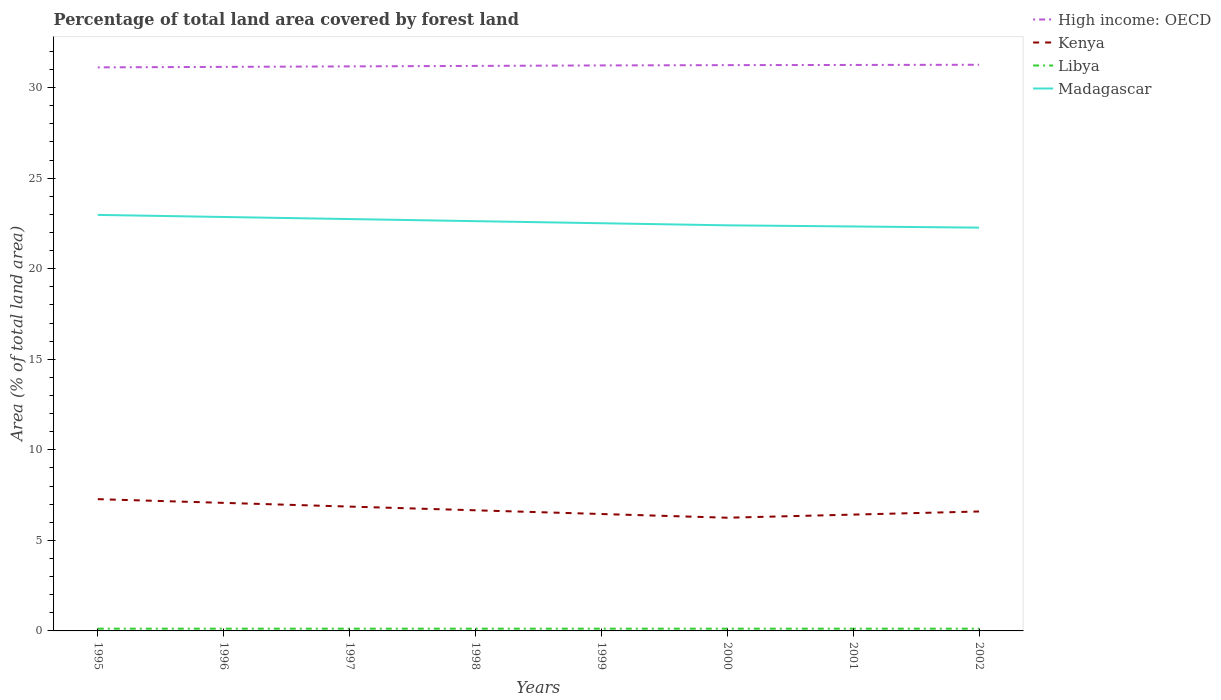How many different coloured lines are there?
Give a very brief answer. 4. Across all years, what is the maximum percentage of forest land in Libya?
Your response must be concise. 0.12. What is the total percentage of forest land in Kenya in the graph?
Provide a short and direct response. 0.27. What is the difference between the highest and the second highest percentage of forest land in Libya?
Provide a short and direct response. 0. How many lines are there?
Offer a terse response. 4. What is the difference between two consecutive major ticks on the Y-axis?
Offer a very short reply. 5. Are the values on the major ticks of Y-axis written in scientific E-notation?
Your answer should be very brief. No. Does the graph contain grids?
Offer a terse response. No. Where does the legend appear in the graph?
Your response must be concise. Top right. How many legend labels are there?
Ensure brevity in your answer.  4. What is the title of the graph?
Keep it short and to the point. Percentage of total land area covered by forest land. What is the label or title of the X-axis?
Your answer should be very brief. Years. What is the label or title of the Y-axis?
Offer a terse response. Area (% of total land area). What is the Area (% of total land area) in High income: OECD in 1995?
Give a very brief answer. 31.12. What is the Area (% of total land area) in Kenya in 1995?
Your answer should be compact. 7.28. What is the Area (% of total land area) of Libya in 1995?
Ensure brevity in your answer.  0.12. What is the Area (% of total land area) in Madagascar in 1995?
Your response must be concise. 22.97. What is the Area (% of total land area) of High income: OECD in 1996?
Offer a terse response. 31.14. What is the Area (% of total land area) of Kenya in 1996?
Your response must be concise. 7.07. What is the Area (% of total land area) of Libya in 1996?
Provide a short and direct response. 0.12. What is the Area (% of total land area) of Madagascar in 1996?
Your answer should be very brief. 22.85. What is the Area (% of total land area) in High income: OECD in 1997?
Offer a very short reply. 31.17. What is the Area (% of total land area) of Kenya in 1997?
Your answer should be compact. 6.86. What is the Area (% of total land area) of Libya in 1997?
Give a very brief answer. 0.12. What is the Area (% of total land area) in Madagascar in 1997?
Keep it short and to the point. 22.74. What is the Area (% of total land area) in High income: OECD in 1998?
Offer a very short reply. 31.2. What is the Area (% of total land area) in Kenya in 1998?
Provide a short and direct response. 6.66. What is the Area (% of total land area) in Libya in 1998?
Keep it short and to the point. 0.12. What is the Area (% of total land area) of Madagascar in 1998?
Your answer should be very brief. 22.62. What is the Area (% of total land area) in High income: OECD in 1999?
Your answer should be compact. 31.22. What is the Area (% of total land area) in Kenya in 1999?
Offer a very short reply. 6.45. What is the Area (% of total land area) of Libya in 1999?
Your answer should be compact. 0.12. What is the Area (% of total land area) of Madagascar in 1999?
Provide a succinct answer. 22.51. What is the Area (% of total land area) in High income: OECD in 2000?
Your answer should be very brief. 31.24. What is the Area (% of total land area) of Kenya in 2000?
Your response must be concise. 6.25. What is the Area (% of total land area) in Libya in 2000?
Provide a succinct answer. 0.12. What is the Area (% of total land area) of Madagascar in 2000?
Make the answer very short. 22.39. What is the Area (% of total land area) in High income: OECD in 2001?
Your answer should be compact. 31.25. What is the Area (% of total land area) of Kenya in 2001?
Offer a very short reply. 6.42. What is the Area (% of total land area) in Libya in 2001?
Offer a very short reply. 0.12. What is the Area (% of total land area) of Madagascar in 2001?
Provide a succinct answer. 22.33. What is the Area (% of total land area) of High income: OECD in 2002?
Your response must be concise. 31.26. What is the Area (% of total land area) in Kenya in 2002?
Your answer should be very brief. 6.59. What is the Area (% of total land area) of Libya in 2002?
Offer a very short reply. 0.12. What is the Area (% of total land area) of Madagascar in 2002?
Provide a succinct answer. 22.27. Across all years, what is the maximum Area (% of total land area) of High income: OECD?
Your answer should be very brief. 31.26. Across all years, what is the maximum Area (% of total land area) of Kenya?
Offer a terse response. 7.28. Across all years, what is the maximum Area (% of total land area) of Libya?
Ensure brevity in your answer.  0.12. Across all years, what is the maximum Area (% of total land area) of Madagascar?
Your response must be concise. 22.97. Across all years, what is the minimum Area (% of total land area) in High income: OECD?
Ensure brevity in your answer.  31.12. Across all years, what is the minimum Area (% of total land area) of Kenya?
Keep it short and to the point. 6.25. Across all years, what is the minimum Area (% of total land area) of Libya?
Your response must be concise. 0.12. Across all years, what is the minimum Area (% of total land area) of Madagascar?
Your response must be concise. 22.27. What is the total Area (% of total land area) in High income: OECD in the graph?
Provide a short and direct response. 249.59. What is the total Area (% of total land area) in Kenya in the graph?
Give a very brief answer. 53.59. What is the total Area (% of total land area) of Libya in the graph?
Offer a very short reply. 0.99. What is the total Area (% of total land area) of Madagascar in the graph?
Ensure brevity in your answer.  180.69. What is the difference between the Area (% of total land area) in High income: OECD in 1995 and that in 1996?
Your answer should be very brief. -0.03. What is the difference between the Area (% of total land area) in Kenya in 1995 and that in 1996?
Your answer should be compact. 0.2. What is the difference between the Area (% of total land area) of Libya in 1995 and that in 1996?
Give a very brief answer. 0. What is the difference between the Area (% of total land area) in Madagascar in 1995 and that in 1996?
Your answer should be compact. 0.12. What is the difference between the Area (% of total land area) of High income: OECD in 1995 and that in 1997?
Ensure brevity in your answer.  -0.05. What is the difference between the Area (% of total land area) in Kenya in 1995 and that in 1997?
Offer a terse response. 0.41. What is the difference between the Area (% of total land area) of Madagascar in 1995 and that in 1997?
Offer a very short reply. 0.23. What is the difference between the Area (% of total land area) in High income: OECD in 1995 and that in 1998?
Your answer should be compact. -0.08. What is the difference between the Area (% of total land area) of Kenya in 1995 and that in 1998?
Your response must be concise. 0.62. What is the difference between the Area (% of total land area) in Madagascar in 1995 and that in 1998?
Keep it short and to the point. 0.35. What is the difference between the Area (% of total land area) in High income: OECD in 1995 and that in 1999?
Provide a short and direct response. -0.11. What is the difference between the Area (% of total land area) of Kenya in 1995 and that in 1999?
Your response must be concise. 0.82. What is the difference between the Area (% of total land area) of Madagascar in 1995 and that in 1999?
Your answer should be compact. 0.46. What is the difference between the Area (% of total land area) in High income: OECD in 1995 and that in 2000?
Your response must be concise. -0.12. What is the difference between the Area (% of total land area) in Kenya in 1995 and that in 2000?
Offer a terse response. 1.03. What is the difference between the Area (% of total land area) in Libya in 1995 and that in 2000?
Your response must be concise. 0. What is the difference between the Area (% of total land area) in Madagascar in 1995 and that in 2000?
Your response must be concise. 0.58. What is the difference between the Area (% of total land area) of High income: OECD in 1995 and that in 2001?
Provide a short and direct response. -0.13. What is the difference between the Area (% of total land area) of Kenya in 1995 and that in 2001?
Ensure brevity in your answer.  0.85. What is the difference between the Area (% of total land area) of Libya in 1995 and that in 2001?
Provide a succinct answer. 0. What is the difference between the Area (% of total land area) of Madagascar in 1995 and that in 2001?
Offer a very short reply. 0.64. What is the difference between the Area (% of total land area) of High income: OECD in 1995 and that in 2002?
Make the answer very short. -0.14. What is the difference between the Area (% of total land area) in Kenya in 1995 and that in 2002?
Your answer should be very brief. 0.68. What is the difference between the Area (% of total land area) of Libya in 1995 and that in 2002?
Make the answer very short. 0. What is the difference between the Area (% of total land area) in Madagascar in 1995 and that in 2002?
Provide a succinct answer. 0.7. What is the difference between the Area (% of total land area) in High income: OECD in 1996 and that in 1997?
Your answer should be compact. -0.03. What is the difference between the Area (% of total land area) in Kenya in 1996 and that in 1997?
Keep it short and to the point. 0.2. What is the difference between the Area (% of total land area) of Madagascar in 1996 and that in 1997?
Give a very brief answer. 0.12. What is the difference between the Area (% of total land area) of High income: OECD in 1996 and that in 1998?
Give a very brief answer. -0.05. What is the difference between the Area (% of total land area) in Kenya in 1996 and that in 1998?
Your response must be concise. 0.41. What is the difference between the Area (% of total land area) in Madagascar in 1996 and that in 1998?
Give a very brief answer. 0.23. What is the difference between the Area (% of total land area) in High income: OECD in 1996 and that in 1999?
Keep it short and to the point. -0.08. What is the difference between the Area (% of total land area) of Kenya in 1996 and that in 1999?
Your answer should be compact. 0.62. What is the difference between the Area (% of total land area) of Libya in 1996 and that in 1999?
Offer a terse response. 0. What is the difference between the Area (% of total land area) in Madagascar in 1996 and that in 1999?
Keep it short and to the point. 0.35. What is the difference between the Area (% of total land area) of High income: OECD in 1996 and that in 2000?
Your response must be concise. -0.1. What is the difference between the Area (% of total land area) of Kenya in 1996 and that in 2000?
Make the answer very short. 0.82. What is the difference between the Area (% of total land area) of Libya in 1996 and that in 2000?
Provide a succinct answer. 0. What is the difference between the Area (% of total land area) in Madagascar in 1996 and that in 2000?
Ensure brevity in your answer.  0.46. What is the difference between the Area (% of total land area) of High income: OECD in 1996 and that in 2001?
Ensure brevity in your answer.  -0.11. What is the difference between the Area (% of total land area) of Kenya in 1996 and that in 2001?
Keep it short and to the point. 0.65. What is the difference between the Area (% of total land area) in Madagascar in 1996 and that in 2001?
Provide a short and direct response. 0.52. What is the difference between the Area (% of total land area) in High income: OECD in 1996 and that in 2002?
Your answer should be compact. -0.12. What is the difference between the Area (% of total land area) of Kenya in 1996 and that in 2002?
Your answer should be very brief. 0.48. What is the difference between the Area (% of total land area) of Libya in 1996 and that in 2002?
Provide a short and direct response. 0. What is the difference between the Area (% of total land area) in Madagascar in 1996 and that in 2002?
Give a very brief answer. 0.59. What is the difference between the Area (% of total land area) in High income: OECD in 1997 and that in 1998?
Your answer should be very brief. -0.03. What is the difference between the Area (% of total land area) of Kenya in 1997 and that in 1998?
Your answer should be very brief. 0.2. What is the difference between the Area (% of total land area) of Madagascar in 1997 and that in 1998?
Offer a very short reply. 0.12. What is the difference between the Area (% of total land area) in High income: OECD in 1997 and that in 1999?
Give a very brief answer. -0.05. What is the difference between the Area (% of total land area) in Kenya in 1997 and that in 1999?
Provide a short and direct response. 0.41. What is the difference between the Area (% of total land area) in Libya in 1997 and that in 1999?
Provide a short and direct response. 0. What is the difference between the Area (% of total land area) in Madagascar in 1997 and that in 1999?
Offer a very short reply. 0.23. What is the difference between the Area (% of total land area) in High income: OECD in 1997 and that in 2000?
Your response must be concise. -0.07. What is the difference between the Area (% of total land area) of Kenya in 1997 and that in 2000?
Give a very brief answer. 0.62. What is the difference between the Area (% of total land area) in Libya in 1997 and that in 2000?
Make the answer very short. 0. What is the difference between the Area (% of total land area) of Madagascar in 1997 and that in 2000?
Your answer should be very brief. 0.35. What is the difference between the Area (% of total land area) in High income: OECD in 1997 and that in 2001?
Keep it short and to the point. -0.08. What is the difference between the Area (% of total land area) of Kenya in 1997 and that in 2001?
Offer a very short reply. 0.44. What is the difference between the Area (% of total land area) of Libya in 1997 and that in 2001?
Offer a terse response. 0. What is the difference between the Area (% of total land area) of Madagascar in 1997 and that in 2001?
Offer a terse response. 0.41. What is the difference between the Area (% of total land area) in High income: OECD in 1997 and that in 2002?
Your answer should be compact. -0.09. What is the difference between the Area (% of total land area) in Kenya in 1997 and that in 2002?
Your response must be concise. 0.27. What is the difference between the Area (% of total land area) in Libya in 1997 and that in 2002?
Offer a terse response. 0. What is the difference between the Area (% of total land area) in Madagascar in 1997 and that in 2002?
Give a very brief answer. 0.47. What is the difference between the Area (% of total land area) of High income: OECD in 1998 and that in 1999?
Your response must be concise. -0.03. What is the difference between the Area (% of total land area) of Kenya in 1998 and that in 1999?
Offer a terse response. 0.2. What is the difference between the Area (% of total land area) in Madagascar in 1998 and that in 1999?
Your answer should be compact. 0.12. What is the difference between the Area (% of total land area) of High income: OECD in 1998 and that in 2000?
Make the answer very short. -0.04. What is the difference between the Area (% of total land area) of Kenya in 1998 and that in 2000?
Your response must be concise. 0.41. What is the difference between the Area (% of total land area) of Madagascar in 1998 and that in 2000?
Offer a very short reply. 0.23. What is the difference between the Area (% of total land area) in High income: OECD in 1998 and that in 2001?
Offer a very short reply. -0.05. What is the difference between the Area (% of total land area) of Kenya in 1998 and that in 2001?
Keep it short and to the point. 0.24. What is the difference between the Area (% of total land area) in Madagascar in 1998 and that in 2001?
Offer a terse response. 0.29. What is the difference between the Area (% of total land area) in High income: OECD in 1998 and that in 2002?
Your answer should be very brief. -0.06. What is the difference between the Area (% of total land area) in Kenya in 1998 and that in 2002?
Offer a very short reply. 0.07. What is the difference between the Area (% of total land area) of Madagascar in 1998 and that in 2002?
Your answer should be very brief. 0.36. What is the difference between the Area (% of total land area) in High income: OECD in 1999 and that in 2000?
Provide a short and direct response. -0.02. What is the difference between the Area (% of total land area) of Kenya in 1999 and that in 2000?
Offer a very short reply. 0.2. What is the difference between the Area (% of total land area) of Libya in 1999 and that in 2000?
Provide a short and direct response. 0. What is the difference between the Area (% of total land area) of Madagascar in 1999 and that in 2000?
Give a very brief answer. 0.12. What is the difference between the Area (% of total land area) of High income: OECD in 1999 and that in 2001?
Your answer should be very brief. -0.03. What is the difference between the Area (% of total land area) of Kenya in 1999 and that in 2001?
Provide a succinct answer. 0.03. What is the difference between the Area (% of total land area) in Libya in 1999 and that in 2001?
Your answer should be compact. 0. What is the difference between the Area (% of total land area) in Madagascar in 1999 and that in 2001?
Give a very brief answer. 0.18. What is the difference between the Area (% of total land area) of High income: OECD in 1999 and that in 2002?
Ensure brevity in your answer.  -0.04. What is the difference between the Area (% of total land area) of Kenya in 1999 and that in 2002?
Make the answer very short. -0.14. What is the difference between the Area (% of total land area) of Madagascar in 1999 and that in 2002?
Provide a succinct answer. 0.24. What is the difference between the Area (% of total land area) of High income: OECD in 2000 and that in 2001?
Your answer should be very brief. -0.01. What is the difference between the Area (% of total land area) in Kenya in 2000 and that in 2001?
Your answer should be compact. -0.17. What is the difference between the Area (% of total land area) of Libya in 2000 and that in 2001?
Your answer should be compact. 0. What is the difference between the Area (% of total land area) in Madagascar in 2000 and that in 2001?
Give a very brief answer. 0.06. What is the difference between the Area (% of total land area) of High income: OECD in 2000 and that in 2002?
Your answer should be very brief. -0.02. What is the difference between the Area (% of total land area) of Kenya in 2000 and that in 2002?
Give a very brief answer. -0.34. What is the difference between the Area (% of total land area) in Madagascar in 2000 and that in 2002?
Provide a succinct answer. 0.13. What is the difference between the Area (% of total land area) in High income: OECD in 2001 and that in 2002?
Ensure brevity in your answer.  -0.01. What is the difference between the Area (% of total land area) in Kenya in 2001 and that in 2002?
Give a very brief answer. -0.17. What is the difference between the Area (% of total land area) in Libya in 2001 and that in 2002?
Your response must be concise. 0. What is the difference between the Area (% of total land area) in Madagascar in 2001 and that in 2002?
Your response must be concise. 0.06. What is the difference between the Area (% of total land area) of High income: OECD in 1995 and the Area (% of total land area) of Kenya in 1996?
Provide a short and direct response. 24.05. What is the difference between the Area (% of total land area) in High income: OECD in 1995 and the Area (% of total land area) in Libya in 1996?
Provide a short and direct response. 30.99. What is the difference between the Area (% of total land area) of High income: OECD in 1995 and the Area (% of total land area) of Madagascar in 1996?
Give a very brief answer. 8.26. What is the difference between the Area (% of total land area) of Kenya in 1995 and the Area (% of total land area) of Libya in 1996?
Provide a short and direct response. 7.15. What is the difference between the Area (% of total land area) of Kenya in 1995 and the Area (% of total land area) of Madagascar in 1996?
Make the answer very short. -15.58. What is the difference between the Area (% of total land area) of Libya in 1995 and the Area (% of total land area) of Madagascar in 1996?
Ensure brevity in your answer.  -22.73. What is the difference between the Area (% of total land area) in High income: OECD in 1995 and the Area (% of total land area) in Kenya in 1997?
Keep it short and to the point. 24.25. What is the difference between the Area (% of total land area) of High income: OECD in 1995 and the Area (% of total land area) of Libya in 1997?
Give a very brief answer. 30.99. What is the difference between the Area (% of total land area) of High income: OECD in 1995 and the Area (% of total land area) of Madagascar in 1997?
Your answer should be compact. 8.38. What is the difference between the Area (% of total land area) of Kenya in 1995 and the Area (% of total land area) of Libya in 1997?
Ensure brevity in your answer.  7.15. What is the difference between the Area (% of total land area) of Kenya in 1995 and the Area (% of total land area) of Madagascar in 1997?
Offer a very short reply. -15.46. What is the difference between the Area (% of total land area) of Libya in 1995 and the Area (% of total land area) of Madagascar in 1997?
Offer a terse response. -22.62. What is the difference between the Area (% of total land area) in High income: OECD in 1995 and the Area (% of total land area) in Kenya in 1998?
Your answer should be very brief. 24.46. What is the difference between the Area (% of total land area) in High income: OECD in 1995 and the Area (% of total land area) in Libya in 1998?
Ensure brevity in your answer.  30.99. What is the difference between the Area (% of total land area) of High income: OECD in 1995 and the Area (% of total land area) of Madagascar in 1998?
Make the answer very short. 8.49. What is the difference between the Area (% of total land area) in Kenya in 1995 and the Area (% of total land area) in Libya in 1998?
Provide a short and direct response. 7.15. What is the difference between the Area (% of total land area) in Kenya in 1995 and the Area (% of total land area) in Madagascar in 1998?
Offer a terse response. -15.35. What is the difference between the Area (% of total land area) in Libya in 1995 and the Area (% of total land area) in Madagascar in 1998?
Your response must be concise. -22.5. What is the difference between the Area (% of total land area) in High income: OECD in 1995 and the Area (% of total land area) in Kenya in 1999?
Provide a succinct answer. 24.66. What is the difference between the Area (% of total land area) in High income: OECD in 1995 and the Area (% of total land area) in Libya in 1999?
Keep it short and to the point. 30.99. What is the difference between the Area (% of total land area) of High income: OECD in 1995 and the Area (% of total land area) of Madagascar in 1999?
Offer a terse response. 8.61. What is the difference between the Area (% of total land area) of Kenya in 1995 and the Area (% of total land area) of Libya in 1999?
Provide a short and direct response. 7.15. What is the difference between the Area (% of total land area) in Kenya in 1995 and the Area (% of total land area) in Madagascar in 1999?
Give a very brief answer. -15.23. What is the difference between the Area (% of total land area) in Libya in 1995 and the Area (% of total land area) in Madagascar in 1999?
Give a very brief answer. -22.39. What is the difference between the Area (% of total land area) of High income: OECD in 1995 and the Area (% of total land area) of Kenya in 2000?
Your answer should be compact. 24.87. What is the difference between the Area (% of total land area) in High income: OECD in 1995 and the Area (% of total land area) in Libya in 2000?
Make the answer very short. 30.99. What is the difference between the Area (% of total land area) in High income: OECD in 1995 and the Area (% of total land area) in Madagascar in 2000?
Provide a short and direct response. 8.72. What is the difference between the Area (% of total land area) in Kenya in 1995 and the Area (% of total land area) in Libya in 2000?
Provide a succinct answer. 7.15. What is the difference between the Area (% of total land area) in Kenya in 1995 and the Area (% of total land area) in Madagascar in 2000?
Make the answer very short. -15.12. What is the difference between the Area (% of total land area) of Libya in 1995 and the Area (% of total land area) of Madagascar in 2000?
Make the answer very short. -22.27. What is the difference between the Area (% of total land area) of High income: OECD in 1995 and the Area (% of total land area) of Kenya in 2001?
Provide a succinct answer. 24.69. What is the difference between the Area (% of total land area) in High income: OECD in 1995 and the Area (% of total land area) in Libya in 2001?
Ensure brevity in your answer.  30.99. What is the difference between the Area (% of total land area) of High income: OECD in 1995 and the Area (% of total land area) of Madagascar in 2001?
Give a very brief answer. 8.78. What is the difference between the Area (% of total land area) of Kenya in 1995 and the Area (% of total land area) of Libya in 2001?
Your response must be concise. 7.15. What is the difference between the Area (% of total land area) in Kenya in 1995 and the Area (% of total land area) in Madagascar in 2001?
Keep it short and to the point. -15.06. What is the difference between the Area (% of total land area) in Libya in 1995 and the Area (% of total land area) in Madagascar in 2001?
Ensure brevity in your answer.  -22.21. What is the difference between the Area (% of total land area) of High income: OECD in 1995 and the Area (% of total land area) of Kenya in 2002?
Provide a short and direct response. 24.52. What is the difference between the Area (% of total land area) in High income: OECD in 1995 and the Area (% of total land area) in Libya in 2002?
Give a very brief answer. 30.99. What is the difference between the Area (% of total land area) in High income: OECD in 1995 and the Area (% of total land area) in Madagascar in 2002?
Give a very brief answer. 8.85. What is the difference between the Area (% of total land area) of Kenya in 1995 and the Area (% of total land area) of Libya in 2002?
Offer a very short reply. 7.15. What is the difference between the Area (% of total land area) in Kenya in 1995 and the Area (% of total land area) in Madagascar in 2002?
Your response must be concise. -14.99. What is the difference between the Area (% of total land area) in Libya in 1995 and the Area (% of total land area) in Madagascar in 2002?
Ensure brevity in your answer.  -22.14. What is the difference between the Area (% of total land area) in High income: OECD in 1996 and the Area (% of total land area) in Kenya in 1997?
Offer a terse response. 24.28. What is the difference between the Area (% of total land area) in High income: OECD in 1996 and the Area (% of total land area) in Libya in 1997?
Your response must be concise. 31.02. What is the difference between the Area (% of total land area) in High income: OECD in 1996 and the Area (% of total land area) in Madagascar in 1997?
Keep it short and to the point. 8.4. What is the difference between the Area (% of total land area) of Kenya in 1996 and the Area (% of total land area) of Libya in 1997?
Provide a short and direct response. 6.95. What is the difference between the Area (% of total land area) in Kenya in 1996 and the Area (% of total land area) in Madagascar in 1997?
Your response must be concise. -15.67. What is the difference between the Area (% of total land area) of Libya in 1996 and the Area (% of total land area) of Madagascar in 1997?
Keep it short and to the point. -22.62. What is the difference between the Area (% of total land area) in High income: OECD in 1996 and the Area (% of total land area) in Kenya in 1998?
Provide a short and direct response. 24.48. What is the difference between the Area (% of total land area) in High income: OECD in 1996 and the Area (% of total land area) in Libya in 1998?
Offer a very short reply. 31.02. What is the difference between the Area (% of total land area) in High income: OECD in 1996 and the Area (% of total land area) in Madagascar in 1998?
Give a very brief answer. 8.52. What is the difference between the Area (% of total land area) in Kenya in 1996 and the Area (% of total land area) in Libya in 1998?
Provide a short and direct response. 6.95. What is the difference between the Area (% of total land area) in Kenya in 1996 and the Area (% of total land area) in Madagascar in 1998?
Provide a short and direct response. -15.55. What is the difference between the Area (% of total land area) in Libya in 1996 and the Area (% of total land area) in Madagascar in 1998?
Ensure brevity in your answer.  -22.5. What is the difference between the Area (% of total land area) of High income: OECD in 1996 and the Area (% of total land area) of Kenya in 1999?
Give a very brief answer. 24.69. What is the difference between the Area (% of total land area) in High income: OECD in 1996 and the Area (% of total land area) in Libya in 1999?
Your answer should be very brief. 31.02. What is the difference between the Area (% of total land area) in High income: OECD in 1996 and the Area (% of total land area) in Madagascar in 1999?
Your response must be concise. 8.63. What is the difference between the Area (% of total land area) in Kenya in 1996 and the Area (% of total land area) in Libya in 1999?
Make the answer very short. 6.95. What is the difference between the Area (% of total land area) in Kenya in 1996 and the Area (% of total land area) in Madagascar in 1999?
Provide a short and direct response. -15.44. What is the difference between the Area (% of total land area) in Libya in 1996 and the Area (% of total land area) in Madagascar in 1999?
Your answer should be compact. -22.39. What is the difference between the Area (% of total land area) of High income: OECD in 1996 and the Area (% of total land area) of Kenya in 2000?
Provide a succinct answer. 24.89. What is the difference between the Area (% of total land area) of High income: OECD in 1996 and the Area (% of total land area) of Libya in 2000?
Make the answer very short. 31.02. What is the difference between the Area (% of total land area) in High income: OECD in 1996 and the Area (% of total land area) in Madagascar in 2000?
Your answer should be compact. 8.75. What is the difference between the Area (% of total land area) of Kenya in 1996 and the Area (% of total land area) of Libya in 2000?
Provide a short and direct response. 6.95. What is the difference between the Area (% of total land area) in Kenya in 1996 and the Area (% of total land area) in Madagascar in 2000?
Make the answer very short. -15.32. What is the difference between the Area (% of total land area) in Libya in 1996 and the Area (% of total land area) in Madagascar in 2000?
Your response must be concise. -22.27. What is the difference between the Area (% of total land area) in High income: OECD in 1996 and the Area (% of total land area) in Kenya in 2001?
Your response must be concise. 24.72. What is the difference between the Area (% of total land area) in High income: OECD in 1996 and the Area (% of total land area) in Libya in 2001?
Offer a terse response. 31.02. What is the difference between the Area (% of total land area) of High income: OECD in 1996 and the Area (% of total land area) of Madagascar in 2001?
Your response must be concise. 8.81. What is the difference between the Area (% of total land area) in Kenya in 1996 and the Area (% of total land area) in Libya in 2001?
Your answer should be compact. 6.95. What is the difference between the Area (% of total land area) of Kenya in 1996 and the Area (% of total land area) of Madagascar in 2001?
Offer a very short reply. -15.26. What is the difference between the Area (% of total land area) in Libya in 1996 and the Area (% of total land area) in Madagascar in 2001?
Your response must be concise. -22.21. What is the difference between the Area (% of total land area) in High income: OECD in 1996 and the Area (% of total land area) in Kenya in 2002?
Offer a very short reply. 24.55. What is the difference between the Area (% of total land area) in High income: OECD in 1996 and the Area (% of total land area) in Libya in 2002?
Provide a short and direct response. 31.02. What is the difference between the Area (% of total land area) of High income: OECD in 1996 and the Area (% of total land area) of Madagascar in 2002?
Give a very brief answer. 8.88. What is the difference between the Area (% of total land area) in Kenya in 1996 and the Area (% of total land area) in Libya in 2002?
Offer a very short reply. 6.95. What is the difference between the Area (% of total land area) in Kenya in 1996 and the Area (% of total land area) in Madagascar in 2002?
Your answer should be very brief. -15.2. What is the difference between the Area (% of total land area) in Libya in 1996 and the Area (% of total land area) in Madagascar in 2002?
Offer a very short reply. -22.14. What is the difference between the Area (% of total land area) in High income: OECD in 1997 and the Area (% of total land area) in Kenya in 1998?
Give a very brief answer. 24.51. What is the difference between the Area (% of total land area) of High income: OECD in 1997 and the Area (% of total land area) of Libya in 1998?
Keep it short and to the point. 31.05. What is the difference between the Area (% of total land area) of High income: OECD in 1997 and the Area (% of total land area) of Madagascar in 1998?
Your answer should be compact. 8.54. What is the difference between the Area (% of total land area) of Kenya in 1997 and the Area (% of total land area) of Libya in 1998?
Offer a very short reply. 6.74. What is the difference between the Area (% of total land area) of Kenya in 1997 and the Area (% of total land area) of Madagascar in 1998?
Make the answer very short. -15.76. What is the difference between the Area (% of total land area) of Libya in 1997 and the Area (% of total land area) of Madagascar in 1998?
Your answer should be compact. -22.5. What is the difference between the Area (% of total land area) in High income: OECD in 1997 and the Area (% of total land area) in Kenya in 1999?
Provide a succinct answer. 24.71. What is the difference between the Area (% of total land area) of High income: OECD in 1997 and the Area (% of total land area) of Libya in 1999?
Your answer should be compact. 31.05. What is the difference between the Area (% of total land area) in High income: OECD in 1997 and the Area (% of total land area) in Madagascar in 1999?
Provide a succinct answer. 8.66. What is the difference between the Area (% of total land area) of Kenya in 1997 and the Area (% of total land area) of Libya in 1999?
Your answer should be compact. 6.74. What is the difference between the Area (% of total land area) of Kenya in 1997 and the Area (% of total land area) of Madagascar in 1999?
Your response must be concise. -15.64. What is the difference between the Area (% of total land area) of Libya in 1997 and the Area (% of total land area) of Madagascar in 1999?
Make the answer very short. -22.39. What is the difference between the Area (% of total land area) of High income: OECD in 1997 and the Area (% of total land area) of Kenya in 2000?
Your answer should be very brief. 24.92. What is the difference between the Area (% of total land area) in High income: OECD in 1997 and the Area (% of total land area) in Libya in 2000?
Ensure brevity in your answer.  31.05. What is the difference between the Area (% of total land area) of High income: OECD in 1997 and the Area (% of total land area) of Madagascar in 2000?
Provide a succinct answer. 8.77. What is the difference between the Area (% of total land area) in Kenya in 1997 and the Area (% of total land area) in Libya in 2000?
Give a very brief answer. 6.74. What is the difference between the Area (% of total land area) of Kenya in 1997 and the Area (% of total land area) of Madagascar in 2000?
Offer a terse response. -15.53. What is the difference between the Area (% of total land area) of Libya in 1997 and the Area (% of total land area) of Madagascar in 2000?
Provide a short and direct response. -22.27. What is the difference between the Area (% of total land area) of High income: OECD in 1997 and the Area (% of total land area) of Kenya in 2001?
Your answer should be compact. 24.75. What is the difference between the Area (% of total land area) in High income: OECD in 1997 and the Area (% of total land area) in Libya in 2001?
Provide a succinct answer. 31.05. What is the difference between the Area (% of total land area) in High income: OECD in 1997 and the Area (% of total land area) in Madagascar in 2001?
Your response must be concise. 8.84. What is the difference between the Area (% of total land area) of Kenya in 1997 and the Area (% of total land area) of Libya in 2001?
Offer a very short reply. 6.74. What is the difference between the Area (% of total land area) of Kenya in 1997 and the Area (% of total land area) of Madagascar in 2001?
Keep it short and to the point. -15.47. What is the difference between the Area (% of total land area) in Libya in 1997 and the Area (% of total land area) in Madagascar in 2001?
Make the answer very short. -22.21. What is the difference between the Area (% of total land area) of High income: OECD in 1997 and the Area (% of total land area) of Kenya in 2002?
Your answer should be compact. 24.57. What is the difference between the Area (% of total land area) of High income: OECD in 1997 and the Area (% of total land area) of Libya in 2002?
Ensure brevity in your answer.  31.05. What is the difference between the Area (% of total land area) of High income: OECD in 1997 and the Area (% of total land area) of Madagascar in 2002?
Give a very brief answer. 8.9. What is the difference between the Area (% of total land area) of Kenya in 1997 and the Area (% of total land area) of Libya in 2002?
Offer a terse response. 6.74. What is the difference between the Area (% of total land area) of Kenya in 1997 and the Area (% of total land area) of Madagascar in 2002?
Provide a succinct answer. -15.4. What is the difference between the Area (% of total land area) in Libya in 1997 and the Area (% of total land area) in Madagascar in 2002?
Your answer should be compact. -22.14. What is the difference between the Area (% of total land area) in High income: OECD in 1998 and the Area (% of total land area) in Kenya in 1999?
Provide a short and direct response. 24.74. What is the difference between the Area (% of total land area) of High income: OECD in 1998 and the Area (% of total land area) of Libya in 1999?
Your answer should be very brief. 31.07. What is the difference between the Area (% of total land area) of High income: OECD in 1998 and the Area (% of total land area) of Madagascar in 1999?
Offer a very short reply. 8.69. What is the difference between the Area (% of total land area) of Kenya in 1998 and the Area (% of total land area) of Libya in 1999?
Your answer should be compact. 6.54. What is the difference between the Area (% of total land area) of Kenya in 1998 and the Area (% of total land area) of Madagascar in 1999?
Make the answer very short. -15.85. What is the difference between the Area (% of total land area) in Libya in 1998 and the Area (% of total land area) in Madagascar in 1999?
Your answer should be very brief. -22.39. What is the difference between the Area (% of total land area) in High income: OECD in 1998 and the Area (% of total land area) in Kenya in 2000?
Your answer should be compact. 24.95. What is the difference between the Area (% of total land area) of High income: OECD in 1998 and the Area (% of total land area) of Libya in 2000?
Provide a succinct answer. 31.07. What is the difference between the Area (% of total land area) in High income: OECD in 1998 and the Area (% of total land area) in Madagascar in 2000?
Offer a very short reply. 8.8. What is the difference between the Area (% of total land area) of Kenya in 1998 and the Area (% of total land area) of Libya in 2000?
Ensure brevity in your answer.  6.54. What is the difference between the Area (% of total land area) of Kenya in 1998 and the Area (% of total land area) of Madagascar in 2000?
Offer a very short reply. -15.73. What is the difference between the Area (% of total land area) of Libya in 1998 and the Area (% of total land area) of Madagascar in 2000?
Your response must be concise. -22.27. What is the difference between the Area (% of total land area) in High income: OECD in 1998 and the Area (% of total land area) in Kenya in 2001?
Your answer should be compact. 24.77. What is the difference between the Area (% of total land area) in High income: OECD in 1998 and the Area (% of total land area) in Libya in 2001?
Ensure brevity in your answer.  31.07. What is the difference between the Area (% of total land area) of High income: OECD in 1998 and the Area (% of total land area) of Madagascar in 2001?
Make the answer very short. 8.87. What is the difference between the Area (% of total land area) of Kenya in 1998 and the Area (% of total land area) of Libya in 2001?
Ensure brevity in your answer.  6.54. What is the difference between the Area (% of total land area) of Kenya in 1998 and the Area (% of total land area) of Madagascar in 2001?
Keep it short and to the point. -15.67. What is the difference between the Area (% of total land area) of Libya in 1998 and the Area (% of total land area) of Madagascar in 2001?
Provide a succinct answer. -22.21. What is the difference between the Area (% of total land area) of High income: OECD in 1998 and the Area (% of total land area) of Kenya in 2002?
Your answer should be compact. 24.6. What is the difference between the Area (% of total land area) in High income: OECD in 1998 and the Area (% of total land area) in Libya in 2002?
Keep it short and to the point. 31.07. What is the difference between the Area (% of total land area) in High income: OECD in 1998 and the Area (% of total land area) in Madagascar in 2002?
Keep it short and to the point. 8.93. What is the difference between the Area (% of total land area) in Kenya in 1998 and the Area (% of total land area) in Libya in 2002?
Give a very brief answer. 6.54. What is the difference between the Area (% of total land area) of Kenya in 1998 and the Area (% of total land area) of Madagascar in 2002?
Your response must be concise. -15.61. What is the difference between the Area (% of total land area) of Libya in 1998 and the Area (% of total land area) of Madagascar in 2002?
Your answer should be compact. -22.14. What is the difference between the Area (% of total land area) of High income: OECD in 1999 and the Area (% of total land area) of Kenya in 2000?
Give a very brief answer. 24.97. What is the difference between the Area (% of total land area) of High income: OECD in 1999 and the Area (% of total land area) of Libya in 2000?
Provide a succinct answer. 31.1. What is the difference between the Area (% of total land area) in High income: OECD in 1999 and the Area (% of total land area) in Madagascar in 2000?
Provide a short and direct response. 8.83. What is the difference between the Area (% of total land area) in Kenya in 1999 and the Area (% of total land area) in Libya in 2000?
Offer a very short reply. 6.33. What is the difference between the Area (% of total land area) of Kenya in 1999 and the Area (% of total land area) of Madagascar in 2000?
Your answer should be very brief. -15.94. What is the difference between the Area (% of total land area) of Libya in 1999 and the Area (% of total land area) of Madagascar in 2000?
Offer a very short reply. -22.27. What is the difference between the Area (% of total land area) in High income: OECD in 1999 and the Area (% of total land area) in Kenya in 2001?
Your answer should be compact. 24.8. What is the difference between the Area (% of total land area) of High income: OECD in 1999 and the Area (% of total land area) of Libya in 2001?
Make the answer very short. 31.1. What is the difference between the Area (% of total land area) in High income: OECD in 1999 and the Area (% of total land area) in Madagascar in 2001?
Keep it short and to the point. 8.89. What is the difference between the Area (% of total land area) of Kenya in 1999 and the Area (% of total land area) of Libya in 2001?
Provide a short and direct response. 6.33. What is the difference between the Area (% of total land area) of Kenya in 1999 and the Area (% of total land area) of Madagascar in 2001?
Provide a succinct answer. -15.88. What is the difference between the Area (% of total land area) in Libya in 1999 and the Area (% of total land area) in Madagascar in 2001?
Ensure brevity in your answer.  -22.21. What is the difference between the Area (% of total land area) of High income: OECD in 1999 and the Area (% of total land area) of Kenya in 2002?
Your answer should be compact. 24.63. What is the difference between the Area (% of total land area) of High income: OECD in 1999 and the Area (% of total land area) of Libya in 2002?
Ensure brevity in your answer.  31.1. What is the difference between the Area (% of total land area) of High income: OECD in 1999 and the Area (% of total land area) of Madagascar in 2002?
Your answer should be very brief. 8.96. What is the difference between the Area (% of total land area) in Kenya in 1999 and the Area (% of total land area) in Libya in 2002?
Keep it short and to the point. 6.33. What is the difference between the Area (% of total land area) of Kenya in 1999 and the Area (% of total land area) of Madagascar in 2002?
Your answer should be compact. -15.81. What is the difference between the Area (% of total land area) in Libya in 1999 and the Area (% of total land area) in Madagascar in 2002?
Ensure brevity in your answer.  -22.14. What is the difference between the Area (% of total land area) in High income: OECD in 2000 and the Area (% of total land area) in Kenya in 2001?
Provide a short and direct response. 24.82. What is the difference between the Area (% of total land area) of High income: OECD in 2000 and the Area (% of total land area) of Libya in 2001?
Provide a succinct answer. 31.11. What is the difference between the Area (% of total land area) in High income: OECD in 2000 and the Area (% of total land area) in Madagascar in 2001?
Offer a terse response. 8.91. What is the difference between the Area (% of total land area) of Kenya in 2000 and the Area (% of total land area) of Libya in 2001?
Your answer should be very brief. 6.13. What is the difference between the Area (% of total land area) in Kenya in 2000 and the Area (% of total land area) in Madagascar in 2001?
Your answer should be very brief. -16.08. What is the difference between the Area (% of total land area) in Libya in 2000 and the Area (% of total land area) in Madagascar in 2001?
Your response must be concise. -22.21. What is the difference between the Area (% of total land area) in High income: OECD in 2000 and the Area (% of total land area) in Kenya in 2002?
Your answer should be very brief. 24.64. What is the difference between the Area (% of total land area) in High income: OECD in 2000 and the Area (% of total land area) in Libya in 2002?
Provide a short and direct response. 31.11. What is the difference between the Area (% of total land area) of High income: OECD in 2000 and the Area (% of total land area) of Madagascar in 2002?
Keep it short and to the point. 8.97. What is the difference between the Area (% of total land area) in Kenya in 2000 and the Area (% of total land area) in Libya in 2002?
Your answer should be compact. 6.13. What is the difference between the Area (% of total land area) in Kenya in 2000 and the Area (% of total land area) in Madagascar in 2002?
Provide a short and direct response. -16.02. What is the difference between the Area (% of total land area) in Libya in 2000 and the Area (% of total land area) in Madagascar in 2002?
Provide a succinct answer. -22.14. What is the difference between the Area (% of total land area) in High income: OECD in 2001 and the Area (% of total land area) in Kenya in 2002?
Keep it short and to the point. 24.65. What is the difference between the Area (% of total land area) of High income: OECD in 2001 and the Area (% of total land area) of Libya in 2002?
Keep it short and to the point. 31.13. What is the difference between the Area (% of total land area) in High income: OECD in 2001 and the Area (% of total land area) in Madagascar in 2002?
Offer a very short reply. 8.98. What is the difference between the Area (% of total land area) in Kenya in 2001 and the Area (% of total land area) in Libya in 2002?
Ensure brevity in your answer.  6.3. What is the difference between the Area (% of total land area) of Kenya in 2001 and the Area (% of total land area) of Madagascar in 2002?
Make the answer very short. -15.84. What is the difference between the Area (% of total land area) in Libya in 2001 and the Area (% of total land area) in Madagascar in 2002?
Give a very brief answer. -22.14. What is the average Area (% of total land area) in High income: OECD per year?
Your response must be concise. 31.2. What is the average Area (% of total land area) in Kenya per year?
Your response must be concise. 6.7. What is the average Area (% of total land area) of Libya per year?
Offer a terse response. 0.12. What is the average Area (% of total land area) of Madagascar per year?
Give a very brief answer. 22.59. In the year 1995, what is the difference between the Area (% of total land area) of High income: OECD and Area (% of total land area) of Kenya?
Provide a short and direct response. 23.84. In the year 1995, what is the difference between the Area (% of total land area) in High income: OECD and Area (% of total land area) in Libya?
Give a very brief answer. 30.99. In the year 1995, what is the difference between the Area (% of total land area) in High income: OECD and Area (% of total land area) in Madagascar?
Keep it short and to the point. 8.15. In the year 1995, what is the difference between the Area (% of total land area) in Kenya and Area (% of total land area) in Libya?
Provide a short and direct response. 7.15. In the year 1995, what is the difference between the Area (% of total land area) of Kenya and Area (% of total land area) of Madagascar?
Give a very brief answer. -15.69. In the year 1995, what is the difference between the Area (% of total land area) of Libya and Area (% of total land area) of Madagascar?
Keep it short and to the point. -22.85. In the year 1996, what is the difference between the Area (% of total land area) of High income: OECD and Area (% of total land area) of Kenya?
Provide a succinct answer. 24.07. In the year 1996, what is the difference between the Area (% of total land area) of High income: OECD and Area (% of total land area) of Libya?
Make the answer very short. 31.02. In the year 1996, what is the difference between the Area (% of total land area) in High income: OECD and Area (% of total land area) in Madagascar?
Give a very brief answer. 8.29. In the year 1996, what is the difference between the Area (% of total land area) in Kenya and Area (% of total land area) in Libya?
Make the answer very short. 6.95. In the year 1996, what is the difference between the Area (% of total land area) of Kenya and Area (% of total land area) of Madagascar?
Your answer should be compact. -15.78. In the year 1996, what is the difference between the Area (% of total land area) of Libya and Area (% of total land area) of Madagascar?
Give a very brief answer. -22.73. In the year 1997, what is the difference between the Area (% of total land area) in High income: OECD and Area (% of total land area) in Kenya?
Ensure brevity in your answer.  24.3. In the year 1997, what is the difference between the Area (% of total land area) of High income: OECD and Area (% of total land area) of Libya?
Offer a terse response. 31.05. In the year 1997, what is the difference between the Area (% of total land area) of High income: OECD and Area (% of total land area) of Madagascar?
Give a very brief answer. 8.43. In the year 1997, what is the difference between the Area (% of total land area) in Kenya and Area (% of total land area) in Libya?
Your answer should be very brief. 6.74. In the year 1997, what is the difference between the Area (% of total land area) of Kenya and Area (% of total land area) of Madagascar?
Your answer should be compact. -15.87. In the year 1997, what is the difference between the Area (% of total land area) of Libya and Area (% of total land area) of Madagascar?
Provide a short and direct response. -22.62. In the year 1998, what is the difference between the Area (% of total land area) of High income: OECD and Area (% of total land area) of Kenya?
Provide a succinct answer. 24.54. In the year 1998, what is the difference between the Area (% of total land area) of High income: OECD and Area (% of total land area) of Libya?
Your answer should be very brief. 31.07. In the year 1998, what is the difference between the Area (% of total land area) of High income: OECD and Area (% of total land area) of Madagascar?
Provide a succinct answer. 8.57. In the year 1998, what is the difference between the Area (% of total land area) in Kenya and Area (% of total land area) in Libya?
Provide a succinct answer. 6.54. In the year 1998, what is the difference between the Area (% of total land area) of Kenya and Area (% of total land area) of Madagascar?
Your response must be concise. -15.96. In the year 1998, what is the difference between the Area (% of total land area) in Libya and Area (% of total land area) in Madagascar?
Make the answer very short. -22.5. In the year 1999, what is the difference between the Area (% of total land area) in High income: OECD and Area (% of total land area) in Kenya?
Provide a short and direct response. 24.77. In the year 1999, what is the difference between the Area (% of total land area) of High income: OECD and Area (% of total land area) of Libya?
Provide a short and direct response. 31.1. In the year 1999, what is the difference between the Area (% of total land area) in High income: OECD and Area (% of total land area) in Madagascar?
Provide a succinct answer. 8.71. In the year 1999, what is the difference between the Area (% of total land area) in Kenya and Area (% of total land area) in Libya?
Offer a very short reply. 6.33. In the year 1999, what is the difference between the Area (% of total land area) in Kenya and Area (% of total land area) in Madagascar?
Offer a terse response. -16.05. In the year 1999, what is the difference between the Area (% of total land area) of Libya and Area (% of total land area) of Madagascar?
Make the answer very short. -22.39. In the year 2000, what is the difference between the Area (% of total land area) in High income: OECD and Area (% of total land area) in Kenya?
Give a very brief answer. 24.99. In the year 2000, what is the difference between the Area (% of total land area) of High income: OECD and Area (% of total land area) of Libya?
Your answer should be very brief. 31.11. In the year 2000, what is the difference between the Area (% of total land area) of High income: OECD and Area (% of total land area) of Madagascar?
Your answer should be very brief. 8.84. In the year 2000, what is the difference between the Area (% of total land area) in Kenya and Area (% of total land area) in Libya?
Give a very brief answer. 6.13. In the year 2000, what is the difference between the Area (% of total land area) of Kenya and Area (% of total land area) of Madagascar?
Provide a succinct answer. -16.14. In the year 2000, what is the difference between the Area (% of total land area) of Libya and Area (% of total land area) of Madagascar?
Ensure brevity in your answer.  -22.27. In the year 2001, what is the difference between the Area (% of total land area) in High income: OECD and Area (% of total land area) in Kenya?
Give a very brief answer. 24.83. In the year 2001, what is the difference between the Area (% of total land area) of High income: OECD and Area (% of total land area) of Libya?
Your answer should be very brief. 31.13. In the year 2001, what is the difference between the Area (% of total land area) of High income: OECD and Area (% of total land area) of Madagascar?
Keep it short and to the point. 8.92. In the year 2001, what is the difference between the Area (% of total land area) of Kenya and Area (% of total land area) of Libya?
Provide a short and direct response. 6.3. In the year 2001, what is the difference between the Area (% of total land area) in Kenya and Area (% of total land area) in Madagascar?
Your response must be concise. -15.91. In the year 2001, what is the difference between the Area (% of total land area) in Libya and Area (% of total land area) in Madagascar?
Your answer should be compact. -22.21. In the year 2002, what is the difference between the Area (% of total land area) in High income: OECD and Area (% of total land area) in Kenya?
Provide a short and direct response. 24.66. In the year 2002, what is the difference between the Area (% of total land area) in High income: OECD and Area (% of total land area) in Libya?
Ensure brevity in your answer.  31.13. In the year 2002, what is the difference between the Area (% of total land area) of High income: OECD and Area (% of total land area) of Madagascar?
Give a very brief answer. 8.99. In the year 2002, what is the difference between the Area (% of total land area) in Kenya and Area (% of total land area) in Libya?
Provide a succinct answer. 6.47. In the year 2002, what is the difference between the Area (% of total land area) in Kenya and Area (% of total land area) in Madagascar?
Offer a terse response. -15.67. In the year 2002, what is the difference between the Area (% of total land area) in Libya and Area (% of total land area) in Madagascar?
Ensure brevity in your answer.  -22.14. What is the ratio of the Area (% of total land area) in Kenya in 1995 to that in 1996?
Give a very brief answer. 1.03. What is the ratio of the Area (% of total land area) of Libya in 1995 to that in 1996?
Ensure brevity in your answer.  1. What is the ratio of the Area (% of total land area) of High income: OECD in 1995 to that in 1997?
Keep it short and to the point. 1. What is the ratio of the Area (% of total land area) of Kenya in 1995 to that in 1997?
Your response must be concise. 1.06. What is the ratio of the Area (% of total land area) in Madagascar in 1995 to that in 1997?
Offer a terse response. 1.01. What is the ratio of the Area (% of total land area) of Kenya in 1995 to that in 1998?
Make the answer very short. 1.09. What is the ratio of the Area (% of total land area) of Madagascar in 1995 to that in 1998?
Provide a succinct answer. 1.02. What is the ratio of the Area (% of total land area) of High income: OECD in 1995 to that in 1999?
Give a very brief answer. 1. What is the ratio of the Area (% of total land area) in Kenya in 1995 to that in 1999?
Your answer should be compact. 1.13. What is the ratio of the Area (% of total land area) of Libya in 1995 to that in 1999?
Your response must be concise. 1. What is the ratio of the Area (% of total land area) of Madagascar in 1995 to that in 1999?
Offer a very short reply. 1.02. What is the ratio of the Area (% of total land area) of Kenya in 1995 to that in 2000?
Your response must be concise. 1.16. What is the ratio of the Area (% of total land area) of Madagascar in 1995 to that in 2000?
Offer a terse response. 1.03. What is the ratio of the Area (% of total land area) of Kenya in 1995 to that in 2001?
Your answer should be very brief. 1.13. What is the ratio of the Area (% of total land area) in Madagascar in 1995 to that in 2001?
Your response must be concise. 1.03. What is the ratio of the Area (% of total land area) in Kenya in 1995 to that in 2002?
Make the answer very short. 1.1. What is the ratio of the Area (% of total land area) in Libya in 1995 to that in 2002?
Your answer should be compact. 1. What is the ratio of the Area (% of total land area) in Madagascar in 1995 to that in 2002?
Your answer should be compact. 1.03. What is the ratio of the Area (% of total land area) in Kenya in 1996 to that in 1997?
Give a very brief answer. 1.03. What is the ratio of the Area (% of total land area) in Madagascar in 1996 to that in 1997?
Keep it short and to the point. 1.01. What is the ratio of the Area (% of total land area) of Kenya in 1996 to that in 1998?
Offer a very short reply. 1.06. What is the ratio of the Area (% of total land area) in Libya in 1996 to that in 1998?
Give a very brief answer. 1. What is the ratio of the Area (% of total land area) of Madagascar in 1996 to that in 1998?
Keep it short and to the point. 1.01. What is the ratio of the Area (% of total land area) of High income: OECD in 1996 to that in 1999?
Keep it short and to the point. 1. What is the ratio of the Area (% of total land area) in Kenya in 1996 to that in 1999?
Give a very brief answer. 1.1. What is the ratio of the Area (% of total land area) of Madagascar in 1996 to that in 1999?
Provide a short and direct response. 1.02. What is the ratio of the Area (% of total land area) of High income: OECD in 1996 to that in 2000?
Provide a short and direct response. 1. What is the ratio of the Area (% of total land area) of Kenya in 1996 to that in 2000?
Your answer should be very brief. 1.13. What is the ratio of the Area (% of total land area) in Madagascar in 1996 to that in 2000?
Offer a very short reply. 1.02. What is the ratio of the Area (% of total land area) in High income: OECD in 1996 to that in 2001?
Provide a succinct answer. 1. What is the ratio of the Area (% of total land area) of Kenya in 1996 to that in 2001?
Your answer should be compact. 1.1. What is the ratio of the Area (% of total land area) in Madagascar in 1996 to that in 2001?
Your answer should be compact. 1.02. What is the ratio of the Area (% of total land area) in Kenya in 1996 to that in 2002?
Provide a short and direct response. 1.07. What is the ratio of the Area (% of total land area) in Madagascar in 1996 to that in 2002?
Offer a terse response. 1.03. What is the ratio of the Area (% of total land area) of High income: OECD in 1997 to that in 1998?
Offer a very short reply. 1. What is the ratio of the Area (% of total land area) of Kenya in 1997 to that in 1998?
Provide a short and direct response. 1.03. What is the ratio of the Area (% of total land area) of Libya in 1997 to that in 1998?
Offer a terse response. 1. What is the ratio of the Area (% of total land area) of High income: OECD in 1997 to that in 1999?
Your response must be concise. 1. What is the ratio of the Area (% of total land area) in Kenya in 1997 to that in 1999?
Your answer should be compact. 1.06. What is the ratio of the Area (% of total land area) in Madagascar in 1997 to that in 1999?
Offer a terse response. 1.01. What is the ratio of the Area (% of total land area) of Kenya in 1997 to that in 2000?
Give a very brief answer. 1.1. What is the ratio of the Area (% of total land area) in Libya in 1997 to that in 2000?
Offer a very short reply. 1. What is the ratio of the Area (% of total land area) of Madagascar in 1997 to that in 2000?
Provide a short and direct response. 1.02. What is the ratio of the Area (% of total land area) in High income: OECD in 1997 to that in 2001?
Your answer should be very brief. 1. What is the ratio of the Area (% of total land area) in Kenya in 1997 to that in 2001?
Keep it short and to the point. 1.07. What is the ratio of the Area (% of total land area) in Madagascar in 1997 to that in 2001?
Ensure brevity in your answer.  1.02. What is the ratio of the Area (% of total land area) of Kenya in 1997 to that in 2002?
Your answer should be compact. 1.04. What is the ratio of the Area (% of total land area) in Madagascar in 1997 to that in 2002?
Your response must be concise. 1.02. What is the ratio of the Area (% of total land area) of Kenya in 1998 to that in 1999?
Your answer should be very brief. 1.03. What is the ratio of the Area (% of total land area) of Libya in 1998 to that in 1999?
Give a very brief answer. 1. What is the ratio of the Area (% of total land area) of High income: OECD in 1998 to that in 2000?
Make the answer very short. 1. What is the ratio of the Area (% of total land area) in Kenya in 1998 to that in 2000?
Keep it short and to the point. 1.07. What is the ratio of the Area (% of total land area) in Madagascar in 1998 to that in 2000?
Make the answer very short. 1.01. What is the ratio of the Area (% of total land area) of Libya in 1998 to that in 2001?
Your answer should be very brief. 1. What is the ratio of the Area (% of total land area) in Madagascar in 1998 to that in 2001?
Provide a short and direct response. 1.01. What is the ratio of the Area (% of total land area) in Kenya in 1998 to that in 2002?
Your response must be concise. 1.01. What is the ratio of the Area (% of total land area) of Madagascar in 1998 to that in 2002?
Your answer should be very brief. 1.02. What is the ratio of the Area (% of total land area) in High income: OECD in 1999 to that in 2000?
Your answer should be very brief. 1. What is the ratio of the Area (% of total land area) in Kenya in 1999 to that in 2000?
Give a very brief answer. 1.03. What is the ratio of the Area (% of total land area) of Libya in 1999 to that in 2000?
Provide a succinct answer. 1. What is the ratio of the Area (% of total land area) in Madagascar in 1999 to that in 2000?
Offer a very short reply. 1.01. What is the ratio of the Area (% of total land area) of High income: OECD in 1999 to that in 2001?
Provide a short and direct response. 1. What is the ratio of the Area (% of total land area) of Kenya in 1999 to that in 2001?
Keep it short and to the point. 1.01. What is the ratio of the Area (% of total land area) of High income: OECD in 1999 to that in 2002?
Provide a short and direct response. 1. What is the ratio of the Area (% of total land area) of Kenya in 1999 to that in 2002?
Your response must be concise. 0.98. What is the ratio of the Area (% of total land area) in Libya in 1999 to that in 2002?
Offer a very short reply. 1. What is the ratio of the Area (% of total land area) in Madagascar in 1999 to that in 2002?
Keep it short and to the point. 1.01. What is the ratio of the Area (% of total land area) in Kenya in 2000 to that in 2001?
Offer a very short reply. 0.97. What is the ratio of the Area (% of total land area) of Libya in 2000 to that in 2001?
Give a very brief answer. 1. What is the ratio of the Area (% of total land area) of Madagascar in 2000 to that in 2001?
Provide a succinct answer. 1. What is the ratio of the Area (% of total land area) in Kenya in 2000 to that in 2002?
Ensure brevity in your answer.  0.95. What is the ratio of the Area (% of total land area) in Libya in 2000 to that in 2002?
Provide a succinct answer. 1. What is the ratio of the Area (% of total land area) in High income: OECD in 2001 to that in 2002?
Your answer should be very brief. 1. What is the ratio of the Area (% of total land area) of Kenya in 2001 to that in 2002?
Give a very brief answer. 0.97. What is the ratio of the Area (% of total land area) of Libya in 2001 to that in 2002?
Your response must be concise. 1. What is the ratio of the Area (% of total land area) of Madagascar in 2001 to that in 2002?
Your answer should be compact. 1. What is the difference between the highest and the second highest Area (% of total land area) in High income: OECD?
Provide a succinct answer. 0.01. What is the difference between the highest and the second highest Area (% of total land area) in Kenya?
Keep it short and to the point. 0.2. What is the difference between the highest and the second highest Area (% of total land area) of Madagascar?
Offer a terse response. 0.12. What is the difference between the highest and the lowest Area (% of total land area) in High income: OECD?
Provide a succinct answer. 0.14. What is the difference between the highest and the lowest Area (% of total land area) of Kenya?
Provide a succinct answer. 1.03. What is the difference between the highest and the lowest Area (% of total land area) of Madagascar?
Offer a terse response. 0.7. 